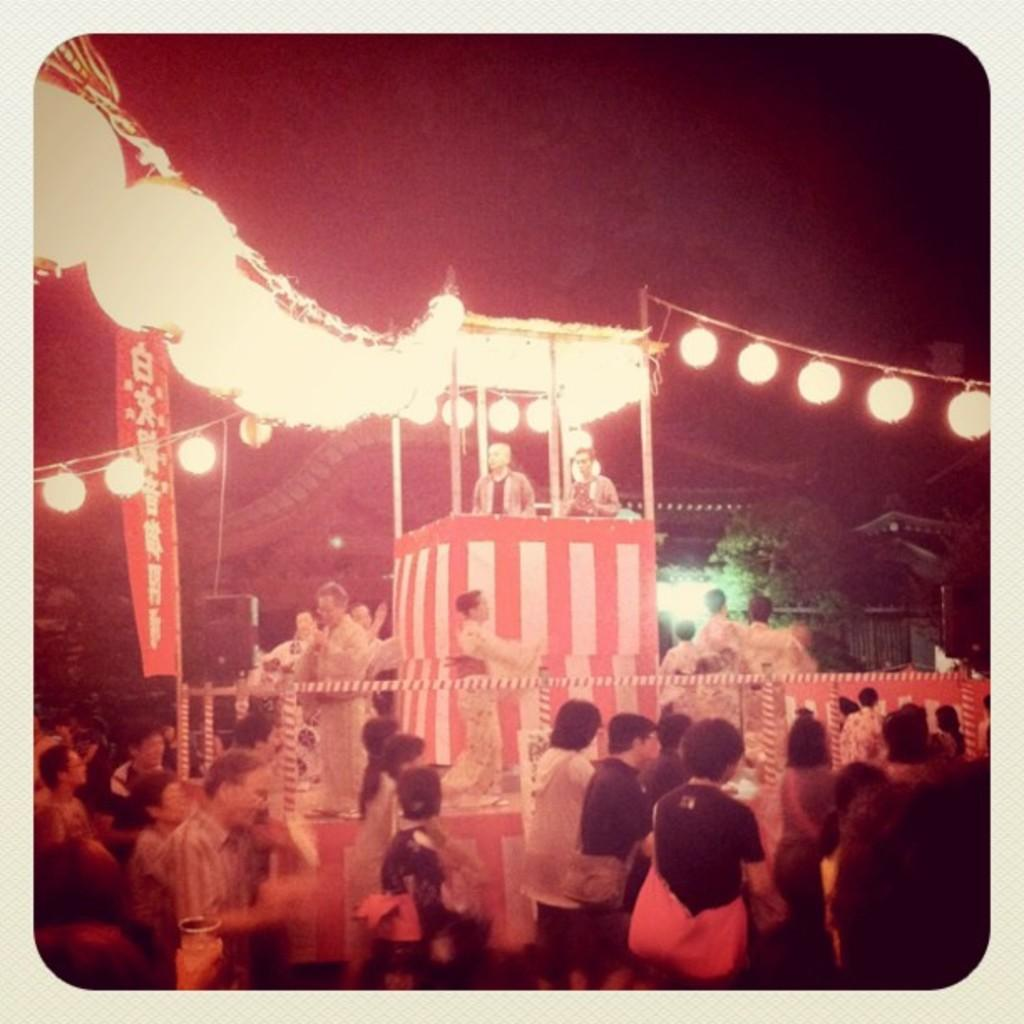What can be seen in the image? There are people standing in the image. What is located in the middle of the image? There are lights in the middle of the image. What is visible in the background of the image? There is a tree in the background of the image. How would you describe the overall lighting in the image? The background of the image is dark. What language are the people speaking in the image? There is no information about the language being spoken in the image. 